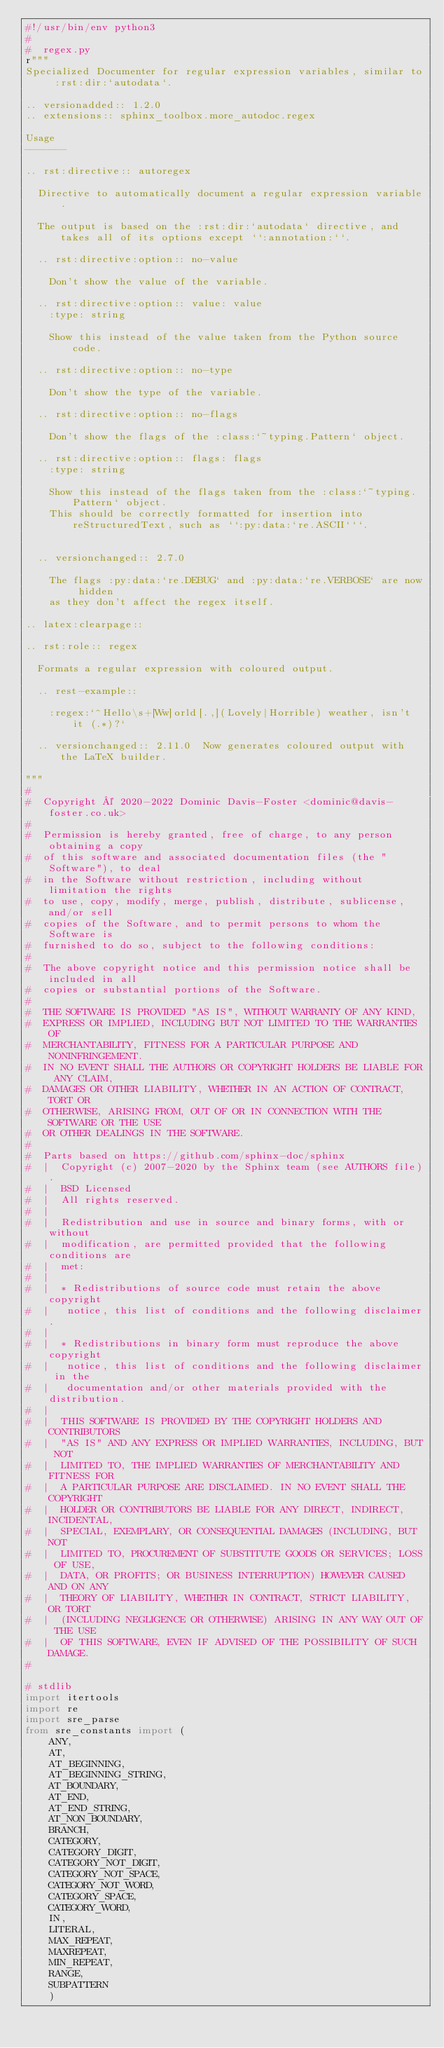<code> <loc_0><loc_0><loc_500><loc_500><_Python_>#!/usr/bin/env python3
#
#  regex.py
r"""
Specialized Documenter for regular expression variables, similar to :rst:dir:`autodata`.

.. versionadded:: 1.2.0
.. extensions:: sphinx_toolbox.more_autodoc.regex

Usage
-------

.. rst:directive:: autoregex

	Directive to automatically document a regular expression variable.

	The output is based on the :rst:dir:`autodata` directive, and takes all of its options except ``:annotation:``.

	.. rst:directive:option:: no-value

		Don't show the value of the variable.

	.. rst:directive:option:: value: value
		:type: string

		Show this instead of the value taken from the Python source code.

	.. rst:directive:option:: no-type

		Don't show the type of the variable.

	.. rst:directive:option:: no-flags

		Don't show the flags of the :class:`~typing.Pattern` object.

	.. rst:directive:option:: flags: flags
		:type: string

		Show this instead of the flags taken from the :class:`~typing.Pattern` object.
		This should be correctly formatted for insertion into reStructuredText, such as ``:py:data:`re.ASCII```.


	.. versionchanged:: 2.7.0

		The flags :py:data:`re.DEBUG` and :py:data:`re.VERBOSE` are now hidden
		as they don't affect the regex itself.

.. latex:clearpage::

.. rst:role:: regex

	Formats a regular expression with coloured output.

	.. rest-example::

		:regex:`^Hello\s+[Ww]orld[.,](Lovely|Horrible) weather, isn't it (.*)?`

	.. versionchanged:: 2.11.0  Now generates coloured output with the LaTeX builder.

"""
#
#  Copyright © 2020-2022 Dominic Davis-Foster <dominic@davis-foster.co.uk>
#
#  Permission is hereby granted, free of charge, to any person obtaining a copy
#  of this software and associated documentation files (the "Software"), to deal
#  in the Software without restriction, including without limitation the rights
#  to use, copy, modify, merge, publish, distribute, sublicense, and/or sell
#  copies of the Software, and to permit persons to whom the Software is
#  furnished to do so, subject to the following conditions:
#
#  The above copyright notice and this permission notice shall be included in all
#  copies or substantial portions of the Software.
#
#  THE SOFTWARE IS PROVIDED "AS IS", WITHOUT WARRANTY OF ANY KIND,
#  EXPRESS OR IMPLIED, INCLUDING BUT NOT LIMITED TO THE WARRANTIES OF
#  MERCHANTABILITY, FITNESS FOR A PARTICULAR PURPOSE AND NONINFRINGEMENT.
#  IN NO EVENT SHALL THE AUTHORS OR COPYRIGHT HOLDERS BE LIABLE FOR ANY CLAIM,
#  DAMAGES OR OTHER LIABILITY, WHETHER IN AN ACTION OF CONTRACT, TORT OR
#  OTHERWISE, ARISING FROM, OUT OF OR IN CONNECTION WITH THE SOFTWARE OR THE USE
#  OR OTHER DEALINGS IN THE SOFTWARE.
#
#  Parts based on https://github.com/sphinx-doc/sphinx
#  |  Copyright (c) 2007-2020 by the Sphinx team (see AUTHORS file).
#  |  BSD Licensed
#  |  All rights reserved.
#  |
#  |  Redistribution and use in source and binary forms, with or without
#  |  modification, are permitted provided that the following conditions are
#  |  met:
#  |
#  |  * Redistributions of source code must retain the above copyright
#  |   notice, this list of conditions and the following disclaimer.
#  |
#  |  * Redistributions in binary form must reproduce the above copyright
#  |   notice, this list of conditions and the following disclaimer in the
#  |   documentation and/or other materials provided with the distribution.
#  |
#  |  THIS SOFTWARE IS PROVIDED BY THE COPYRIGHT HOLDERS AND CONTRIBUTORS
#  |  "AS IS" AND ANY EXPRESS OR IMPLIED WARRANTIES, INCLUDING, BUT NOT
#  |  LIMITED TO, THE IMPLIED WARRANTIES OF MERCHANTABILITY AND FITNESS FOR
#  |  A PARTICULAR PURPOSE ARE DISCLAIMED. IN NO EVENT SHALL THE COPYRIGHT
#  |  HOLDER OR CONTRIBUTORS BE LIABLE FOR ANY DIRECT, INDIRECT, INCIDENTAL,
#  |  SPECIAL, EXEMPLARY, OR CONSEQUENTIAL DAMAGES (INCLUDING, BUT NOT
#  |  LIMITED TO, PROCUREMENT OF SUBSTITUTE GOODS OR SERVICES; LOSS OF USE,
#  |  DATA, OR PROFITS; OR BUSINESS INTERRUPTION) HOWEVER CAUSED AND ON ANY
#  |  THEORY OF LIABILITY, WHETHER IN CONTRACT, STRICT LIABILITY, OR TORT
#  |  (INCLUDING NEGLIGENCE OR OTHERWISE) ARISING IN ANY WAY OUT OF THE USE
#  |  OF THIS SOFTWARE, EVEN IF ADVISED OF THE POSSIBILITY OF SUCH DAMAGE.
#

# stdlib
import itertools
import re
import sre_parse
from sre_constants import (
		ANY,
		AT,
		AT_BEGINNING,
		AT_BEGINNING_STRING,
		AT_BOUNDARY,
		AT_END,
		AT_END_STRING,
		AT_NON_BOUNDARY,
		BRANCH,
		CATEGORY,
		CATEGORY_DIGIT,
		CATEGORY_NOT_DIGIT,
		CATEGORY_NOT_SPACE,
		CATEGORY_NOT_WORD,
		CATEGORY_SPACE,
		CATEGORY_WORD,
		IN,
		LITERAL,
		MAX_REPEAT,
		MAXREPEAT,
		MIN_REPEAT,
		RANGE,
		SUBPATTERN
		)</code> 